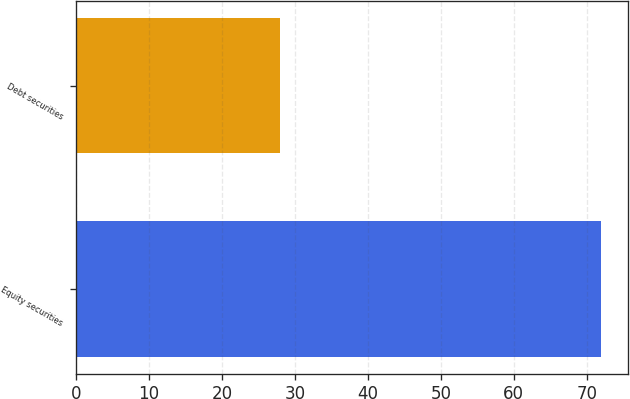Convert chart to OTSL. <chart><loc_0><loc_0><loc_500><loc_500><bar_chart><fcel>Equity securities<fcel>Debt securities<nl><fcel>72<fcel>28<nl></chart> 